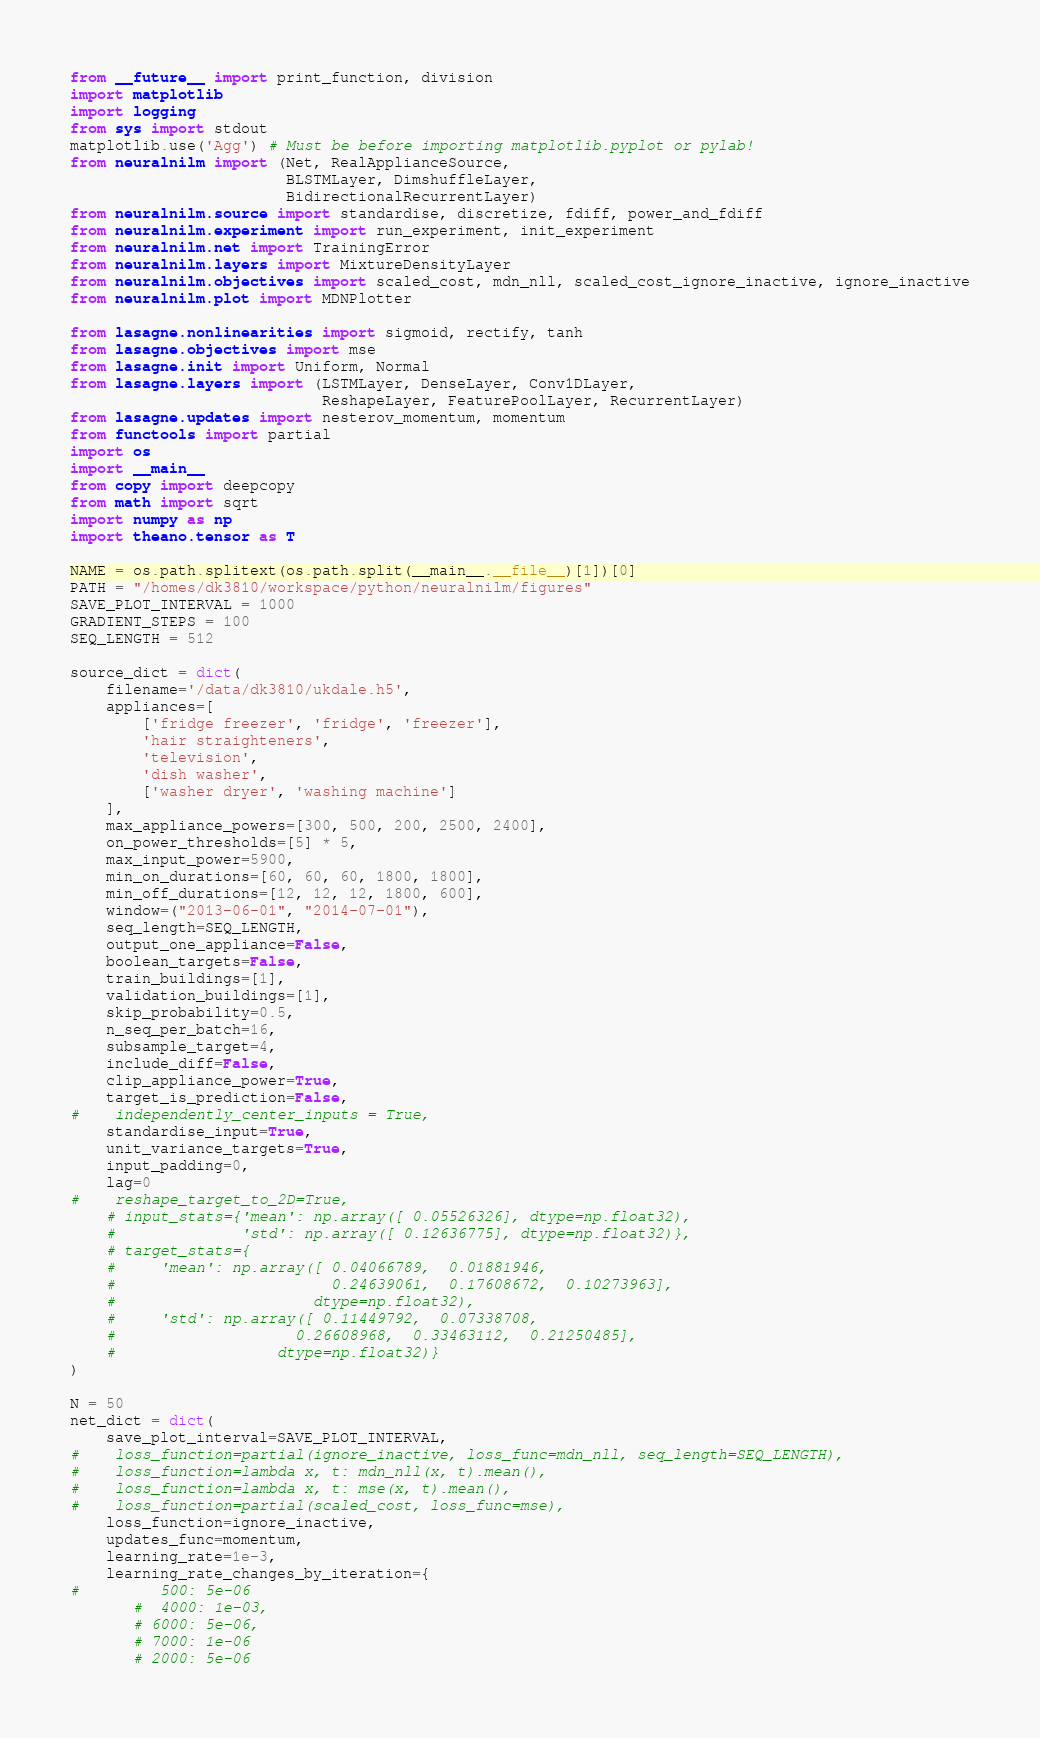<code> <loc_0><loc_0><loc_500><loc_500><_Python_>from __future__ import print_function, division
import matplotlib
import logging
from sys import stdout
matplotlib.use('Agg') # Must be before importing matplotlib.pyplot or pylab!
from neuralnilm import (Net, RealApplianceSource, 
                        BLSTMLayer, DimshuffleLayer, 
                        BidirectionalRecurrentLayer)
from neuralnilm.source import standardise, discretize, fdiff, power_and_fdiff
from neuralnilm.experiment import run_experiment, init_experiment
from neuralnilm.net import TrainingError
from neuralnilm.layers import MixtureDensityLayer
from neuralnilm.objectives import scaled_cost, mdn_nll, scaled_cost_ignore_inactive, ignore_inactive
from neuralnilm.plot import MDNPlotter

from lasagne.nonlinearities import sigmoid, rectify, tanh
from lasagne.objectives import mse
from lasagne.init import Uniform, Normal
from lasagne.layers import (LSTMLayer, DenseLayer, Conv1DLayer, 
                            ReshapeLayer, FeaturePoolLayer, RecurrentLayer)
from lasagne.updates import nesterov_momentum, momentum
from functools import partial
import os
import __main__
from copy import deepcopy
from math import sqrt
import numpy as np
import theano.tensor as T

NAME = os.path.splitext(os.path.split(__main__.__file__)[1])[0]
PATH = "/homes/dk3810/workspace/python/neuralnilm/figures"
SAVE_PLOT_INTERVAL = 1000
GRADIENT_STEPS = 100
SEQ_LENGTH = 512

source_dict = dict(
    filename='/data/dk3810/ukdale.h5',
    appliances=[
        ['fridge freezer', 'fridge', 'freezer'], 
        'hair straighteners', 
        'television',
        'dish washer',
        ['washer dryer', 'washing machine']
    ],
    max_appliance_powers=[300, 500, 200, 2500, 2400],
    on_power_thresholds=[5] * 5,
    max_input_power=5900,
    min_on_durations=[60, 60, 60, 1800, 1800],
    min_off_durations=[12, 12, 12, 1800, 600],
    window=("2013-06-01", "2014-07-01"),
    seq_length=SEQ_LENGTH,
    output_one_appliance=False,
    boolean_targets=False,
    train_buildings=[1],
    validation_buildings=[1], 
    skip_probability=0.5,
    n_seq_per_batch=16,
    subsample_target=4,
    include_diff=False,
    clip_appliance_power=True,
    target_is_prediction=False,
#    independently_center_inputs = True,
    standardise_input=True,
    unit_variance_targets=True,
    input_padding=0,
    lag=0
#    reshape_target_to_2D=True,
    # input_stats={'mean': np.array([ 0.05526326], dtype=np.float32),
    #              'std': np.array([ 0.12636775], dtype=np.float32)},
    # target_stats={
    #     'mean': np.array([ 0.04066789,  0.01881946,  
    #                        0.24639061,  0.17608672,  0.10273963], 
    #                      dtype=np.float32),
    #     'std': np.array([ 0.11449792,  0.07338708,  
    #                    0.26608968,  0.33463112,  0.21250485], 
    #                  dtype=np.float32)}
)

N = 50
net_dict = dict(        
    save_plot_interval=SAVE_PLOT_INTERVAL,
#    loss_function=partial(ignore_inactive, loss_func=mdn_nll, seq_length=SEQ_LENGTH),
#    loss_function=lambda x, t: mdn_nll(x, t).mean(),
#    loss_function=lambda x, t: mse(x, t).mean(),
#    loss_function=partial(scaled_cost, loss_func=mse),
    loss_function=ignore_inactive,
    updates_func=momentum,
    learning_rate=1e-3,
    learning_rate_changes_by_iteration={
#         500: 5e-06
       #  4000: 1e-03,
       # 6000: 5e-06,
       # 7000: 1e-06
       # 2000: 5e-06</code> 